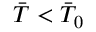<formula> <loc_0><loc_0><loc_500><loc_500>\ B a r { T } < \ B a r { T } _ { 0 }</formula> 